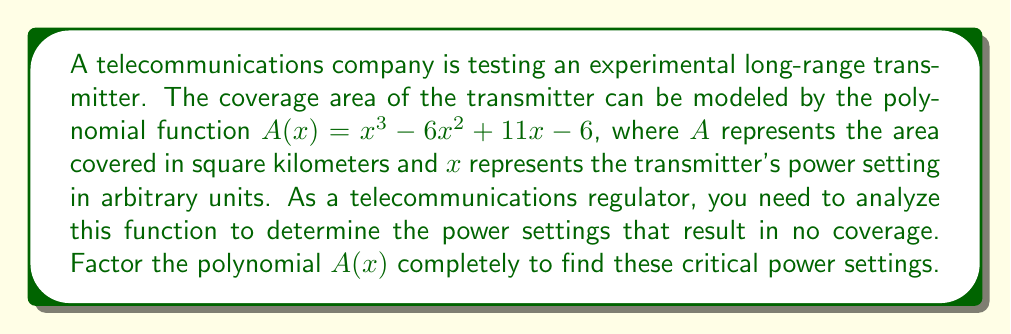Help me with this question. To factor the polynomial $A(x) = x^3 - 6x^2 + 11x - 6$, we'll follow these steps:

1) First, let's check if there's a common factor. There isn't, so we proceed to the next step.

2) This is a cubic polynomial. Let's try to find a root by guessing some factors of the constant term (-6). Possible factors are ±1, ±2, ±3, ±6.

3) Testing these values, we find that $A(1) = 1 - 6 + 11 - 6 = 0$. So, $(x-1)$ is a factor.

4) We can now use polynomial long division or synthetic division to find the other factor:

   $x^3 - 6x^2 + 11x - 6 = (x-1)(x^2 - 5x + 6)$

5) The quadratic factor $x^2 - 5x + 6$ can be factored further:

   $x^2 - 5x + 6 = (x-2)(x-3)$

6) Therefore, the complete factorization is:

   $A(x) = (x-1)(x-2)(x-3)$

The roots of this polynomial, which represent the power settings resulting in no coverage, are $x = 1$, $x = 2$, and $x = 3$.
Answer: $A(x) = (x-1)(x-2)(x-3)$ 